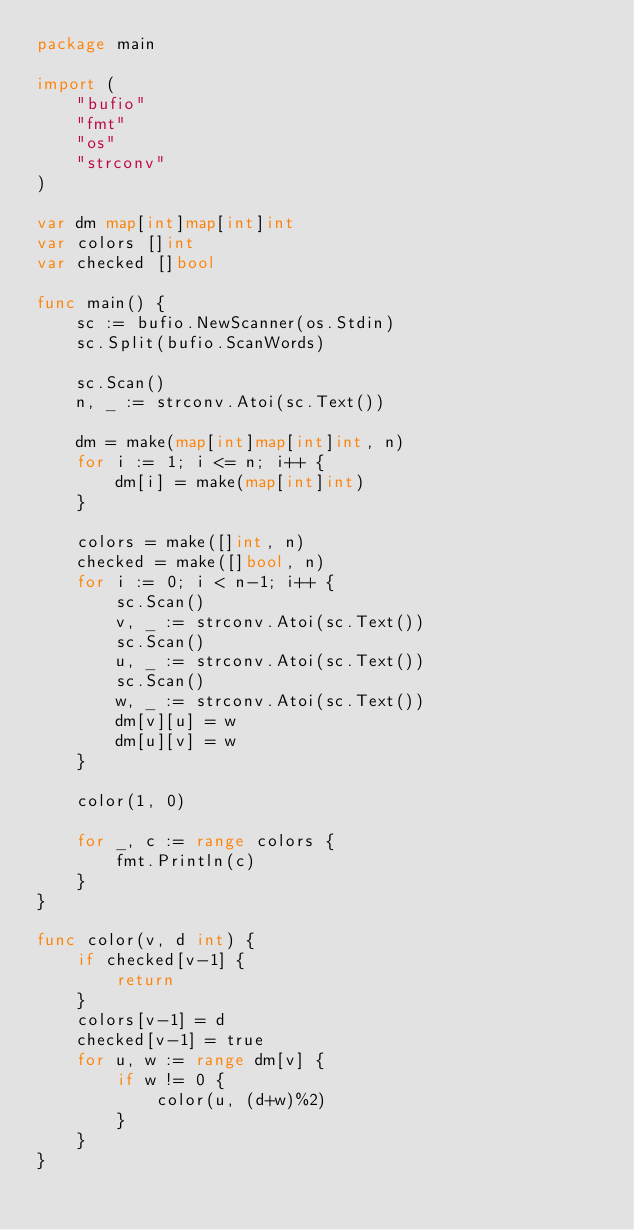Convert code to text. <code><loc_0><loc_0><loc_500><loc_500><_Go_>package main

import (
	"bufio"
	"fmt"
	"os"
	"strconv"
)

var dm map[int]map[int]int
var colors []int
var checked []bool

func main() {
	sc := bufio.NewScanner(os.Stdin)
	sc.Split(bufio.ScanWords)

	sc.Scan()
	n, _ := strconv.Atoi(sc.Text())

	dm = make(map[int]map[int]int, n)
	for i := 1; i <= n; i++ {
		dm[i] = make(map[int]int)
	}

	colors = make([]int, n)
	checked = make([]bool, n)
	for i := 0; i < n-1; i++ {
		sc.Scan()
		v, _ := strconv.Atoi(sc.Text())
		sc.Scan()
		u, _ := strconv.Atoi(sc.Text())
		sc.Scan()
		w, _ := strconv.Atoi(sc.Text())
		dm[v][u] = w
		dm[u][v] = w
	}

	color(1, 0)

	for _, c := range colors {
		fmt.Println(c)
	}
}

func color(v, d int) {
	if checked[v-1] {
		return
	}
	colors[v-1] = d
	checked[v-1] = true
	for u, w := range dm[v] {
		if w != 0 {
			color(u, (d+w)%2)
		}
	}
}
</code> 